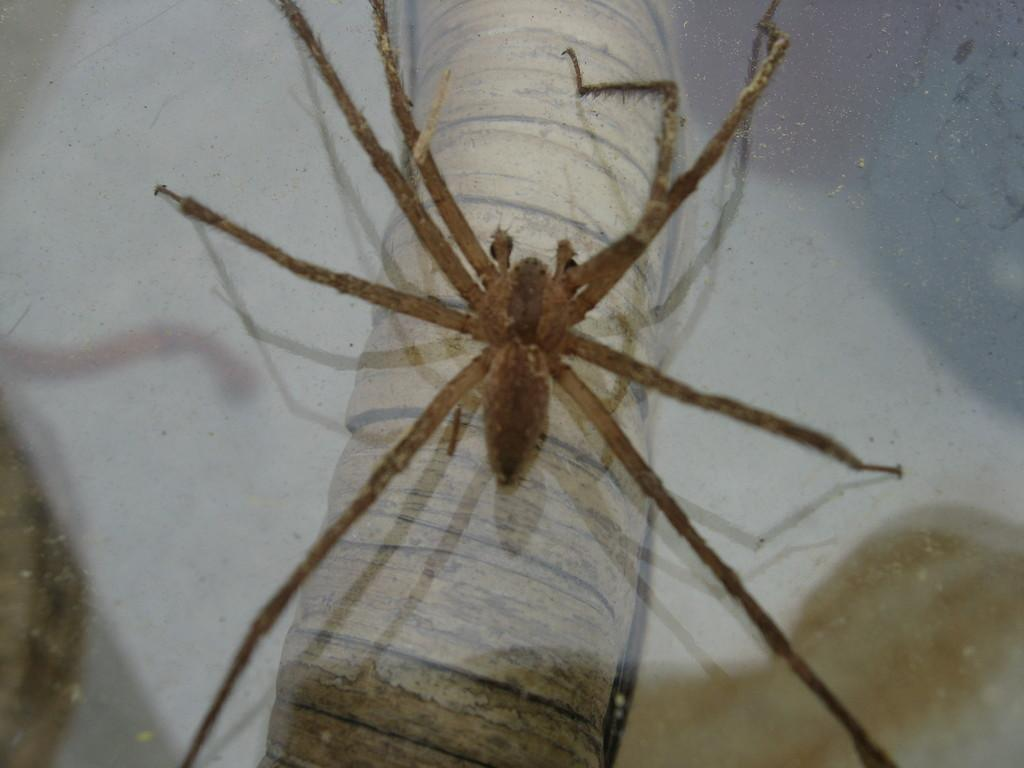What is present in the image? There is a fly in the image. Where is the fly located? The fly is on a surface. What type of vest is the fly wearing in the image? There is no vest present in the image, as the subject is a fly and not a person. 